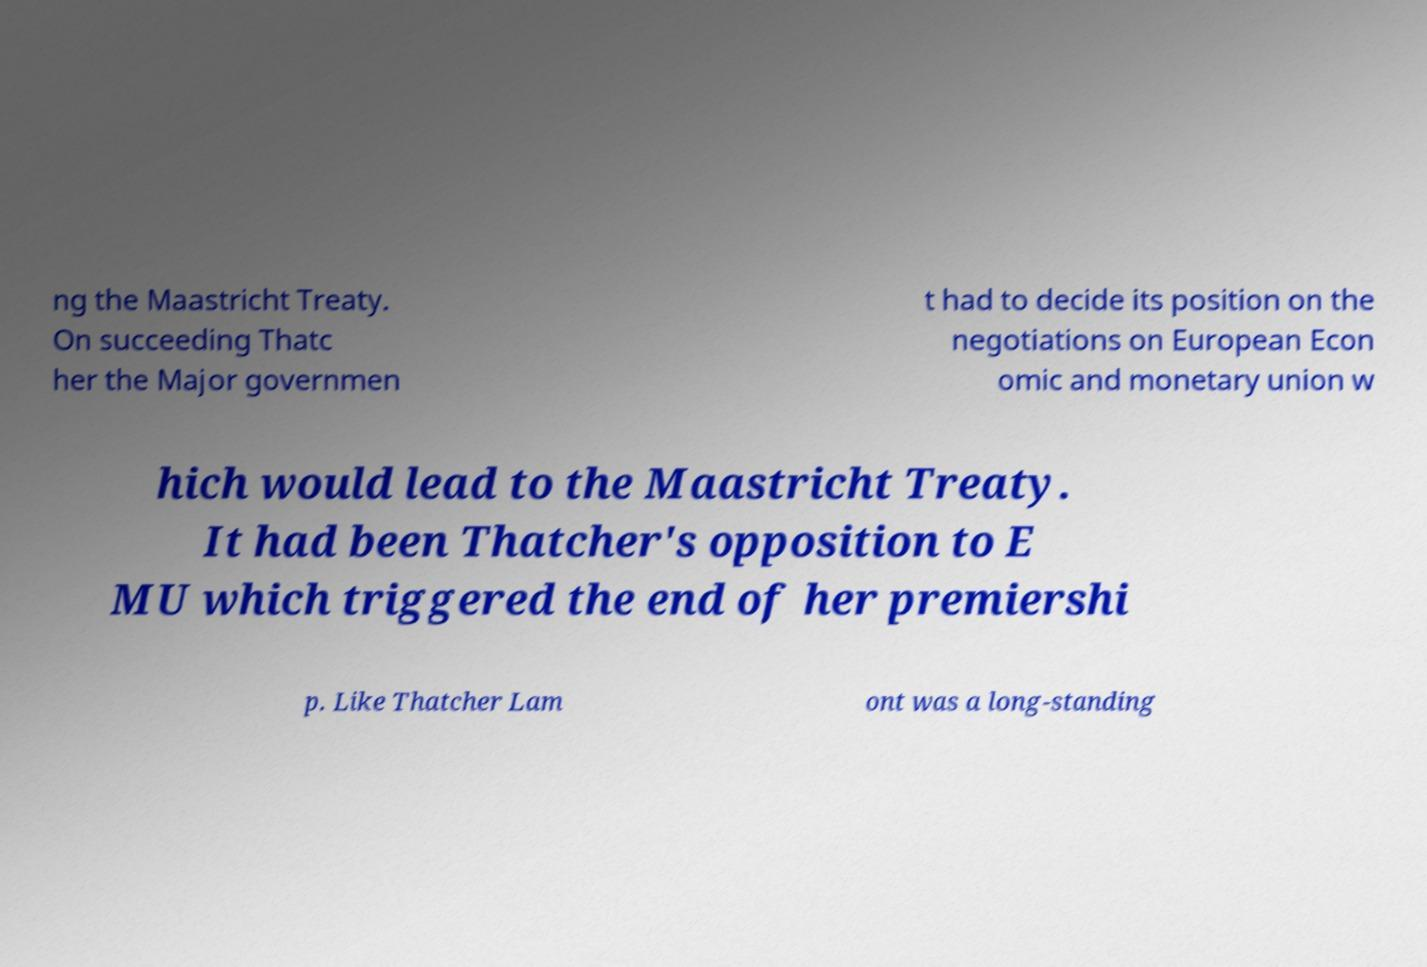Please identify and transcribe the text found in this image. ng the Maastricht Treaty. On succeeding Thatc her the Major governmen t had to decide its position on the negotiations on European Econ omic and monetary union w hich would lead to the Maastricht Treaty. It had been Thatcher's opposition to E MU which triggered the end of her premiershi p. Like Thatcher Lam ont was a long-standing 